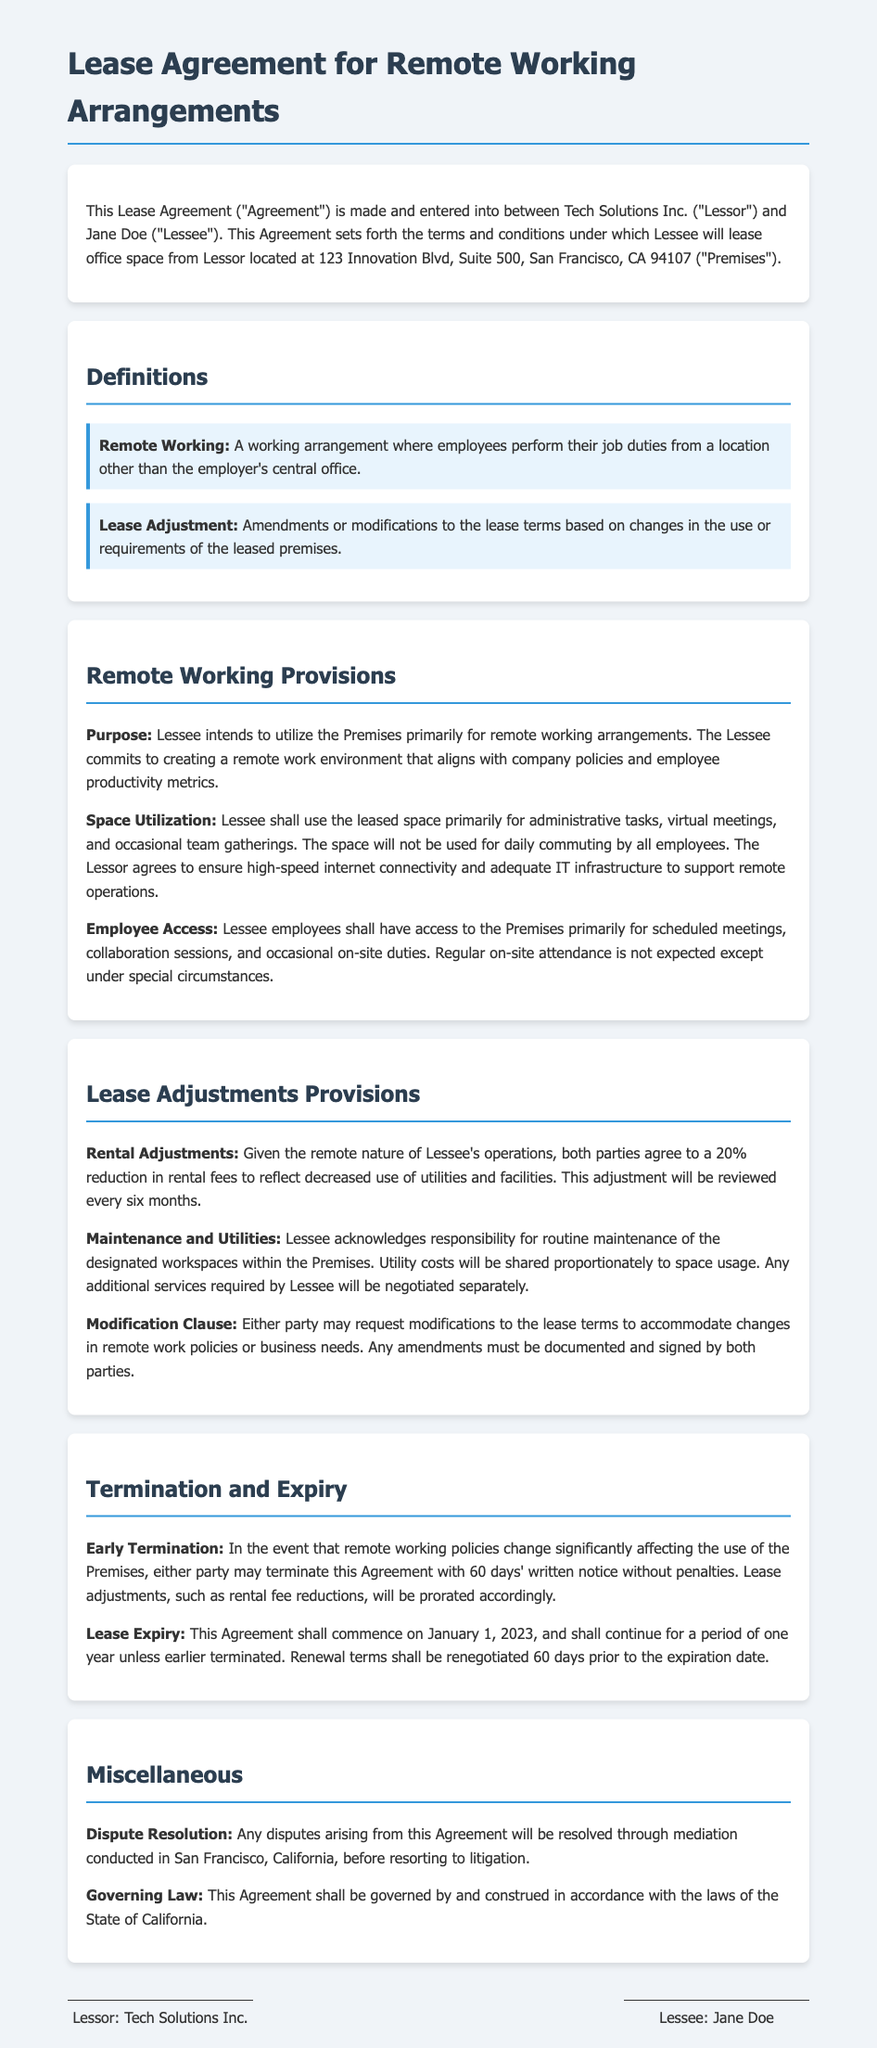What is the name of the Lessor? The name of the Lessor is stated in the introduction of the document as Tech Solutions Inc.
Answer: Tech Solutions Inc What is the address of the Premises? The address of the Premises is provided in the introductory section of the document.
Answer: 123 Innovation Blvd, Suite 500, San Francisco, CA 94107 What is the percentage reduction in rental fees? The document specifies a 20% reduction in rental fees due to remote operations.
Answer: 20% How often will rental adjustments be reviewed? The frequency of rental adjustment reviews is mentioned in the provisions.
Answer: Every six months What is required for early termination of the Agreement? The conditions for early termination specify that it requires 60 days' written notice.
Answer: 60 days' written notice What is the duration of the initial lease period? The duration of the lease is mentioned under the Lease Expiry section of the document.
Answer: One year Which party is responsible for routine maintenance? The document clarifies responsibility for routine maintenance in the Lease Adjustments Provisions.
Answer: Lessee What must be documented to make lease modifications? The modifications to the lease terms require both parties to sign a document according to the Modification Clause.
Answer: Signed by both parties Where will disputes be resolved? The document states that disputes will be resolved in a specific location.
Answer: San Francisco, California 